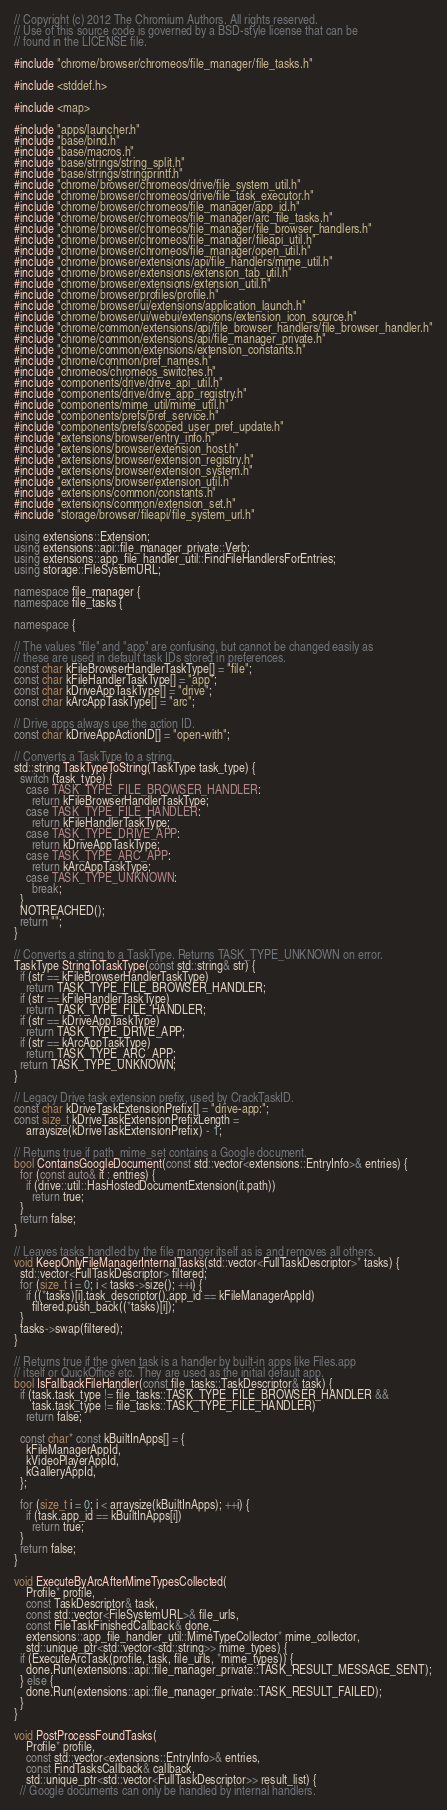<code> <loc_0><loc_0><loc_500><loc_500><_C++_>// Copyright (c) 2012 The Chromium Authors. All rights reserved.
// Use of this source code is governed by a BSD-style license that can be
// found in the LICENSE file.

#include "chrome/browser/chromeos/file_manager/file_tasks.h"

#include <stddef.h>

#include <map>

#include "apps/launcher.h"
#include "base/bind.h"
#include "base/macros.h"
#include "base/strings/string_split.h"
#include "base/strings/stringprintf.h"
#include "chrome/browser/chromeos/drive/file_system_util.h"
#include "chrome/browser/chromeos/drive/file_task_executor.h"
#include "chrome/browser/chromeos/file_manager/app_id.h"
#include "chrome/browser/chromeos/file_manager/arc_file_tasks.h"
#include "chrome/browser/chromeos/file_manager/file_browser_handlers.h"
#include "chrome/browser/chromeos/file_manager/fileapi_util.h"
#include "chrome/browser/chromeos/file_manager/open_util.h"
#include "chrome/browser/extensions/api/file_handlers/mime_util.h"
#include "chrome/browser/extensions/extension_tab_util.h"
#include "chrome/browser/extensions/extension_util.h"
#include "chrome/browser/profiles/profile.h"
#include "chrome/browser/ui/extensions/application_launch.h"
#include "chrome/browser/ui/webui/extensions/extension_icon_source.h"
#include "chrome/common/extensions/api/file_browser_handlers/file_browser_handler.h"
#include "chrome/common/extensions/api/file_manager_private.h"
#include "chrome/common/extensions/extension_constants.h"
#include "chrome/common/pref_names.h"
#include "chromeos/chromeos_switches.h"
#include "components/drive/drive_api_util.h"
#include "components/drive/drive_app_registry.h"
#include "components/mime_util/mime_util.h"
#include "components/prefs/pref_service.h"
#include "components/prefs/scoped_user_pref_update.h"
#include "extensions/browser/entry_info.h"
#include "extensions/browser/extension_host.h"
#include "extensions/browser/extension_registry.h"
#include "extensions/browser/extension_system.h"
#include "extensions/browser/extension_util.h"
#include "extensions/common/constants.h"
#include "extensions/common/extension_set.h"
#include "storage/browser/fileapi/file_system_url.h"

using extensions::Extension;
using extensions::api::file_manager_private::Verb;
using extensions::app_file_handler_util::FindFileHandlersForEntries;
using storage::FileSystemURL;

namespace file_manager {
namespace file_tasks {

namespace {

// The values "file" and "app" are confusing, but cannot be changed easily as
// these are used in default task IDs stored in preferences.
const char kFileBrowserHandlerTaskType[] = "file";
const char kFileHandlerTaskType[] = "app";
const char kDriveAppTaskType[] = "drive";
const char kArcAppTaskType[] = "arc";

// Drive apps always use the action ID.
const char kDriveAppActionID[] = "open-with";

// Converts a TaskType to a string.
std::string TaskTypeToString(TaskType task_type) {
  switch (task_type) {
    case TASK_TYPE_FILE_BROWSER_HANDLER:
      return kFileBrowserHandlerTaskType;
    case TASK_TYPE_FILE_HANDLER:
      return kFileHandlerTaskType;
    case TASK_TYPE_DRIVE_APP:
      return kDriveAppTaskType;
    case TASK_TYPE_ARC_APP:
      return kArcAppTaskType;
    case TASK_TYPE_UNKNOWN:
      break;
  }
  NOTREACHED();
  return "";
}

// Converts a string to a TaskType. Returns TASK_TYPE_UNKNOWN on error.
TaskType StringToTaskType(const std::string& str) {
  if (str == kFileBrowserHandlerTaskType)
    return TASK_TYPE_FILE_BROWSER_HANDLER;
  if (str == kFileHandlerTaskType)
    return TASK_TYPE_FILE_HANDLER;
  if (str == kDriveAppTaskType)
    return TASK_TYPE_DRIVE_APP;
  if (str == kArcAppTaskType)
    return TASK_TYPE_ARC_APP;
  return TASK_TYPE_UNKNOWN;
}

// Legacy Drive task extension prefix, used by CrackTaskID.
const char kDriveTaskExtensionPrefix[] = "drive-app:";
const size_t kDriveTaskExtensionPrefixLength =
    arraysize(kDriveTaskExtensionPrefix) - 1;

// Returns true if path_mime_set contains a Google document.
bool ContainsGoogleDocument(const std::vector<extensions::EntryInfo>& entries) {
  for (const auto& it : entries) {
    if (drive::util::HasHostedDocumentExtension(it.path))
      return true;
  }
  return false;
}

// Leaves tasks handled by the file manger itself as is and removes all others.
void KeepOnlyFileManagerInternalTasks(std::vector<FullTaskDescriptor>* tasks) {
  std::vector<FullTaskDescriptor> filtered;
  for (size_t i = 0; i < tasks->size(); ++i) {
    if ((*tasks)[i].task_descriptor().app_id == kFileManagerAppId)
      filtered.push_back((*tasks)[i]);
  }
  tasks->swap(filtered);
}

// Returns true if the given task is a handler by built-in apps like Files.app
// itself or QuickOffice etc. They are used as the initial default app.
bool IsFallbackFileHandler(const file_tasks::TaskDescriptor& task) {
  if (task.task_type != file_tasks::TASK_TYPE_FILE_BROWSER_HANDLER &&
      task.task_type != file_tasks::TASK_TYPE_FILE_HANDLER)
    return false;

  const char* const kBuiltInApps[] = {
    kFileManagerAppId,
    kVideoPlayerAppId,
    kGalleryAppId,
  };

  for (size_t i = 0; i < arraysize(kBuiltInApps); ++i) {
    if (task.app_id == kBuiltInApps[i])
      return true;
  }
  return false;
}

void ExecuteByArcAfterMimeTypesCollected(
    Profile* profile,
    const TaskDescriptor& task,
    const std::vector<FileSystemURL>& file_urls,
    const FileTaskFinishedCallback& done,
    extensions::app_file_handler_util::MimeTypeCollector* mime_collector,
    std::unique_ptr<std::vector<std::string>> mime_types) {
  if (ExecuteArcTask(profile, task, file_urls, *mime_types)) {
    done.Run(extensions::api::file_manager_private::TASK_RESULT_MESSAGE_SENT);
  } else {
    done.Run(extensions::api::file_manager_private::TASK_RESULT_FAILED);
  }
}

void PostProcessFoundTasks(
    Profile* profile,
    const std::vector<extensions::EntryInfo>& entries,
    const FindTasksCallback& callback,
    std::unique_ptr<std::vector<FullTaskDescriptor>> result_list) {
  // Google documents can only be handled by internal handlers.</code> 